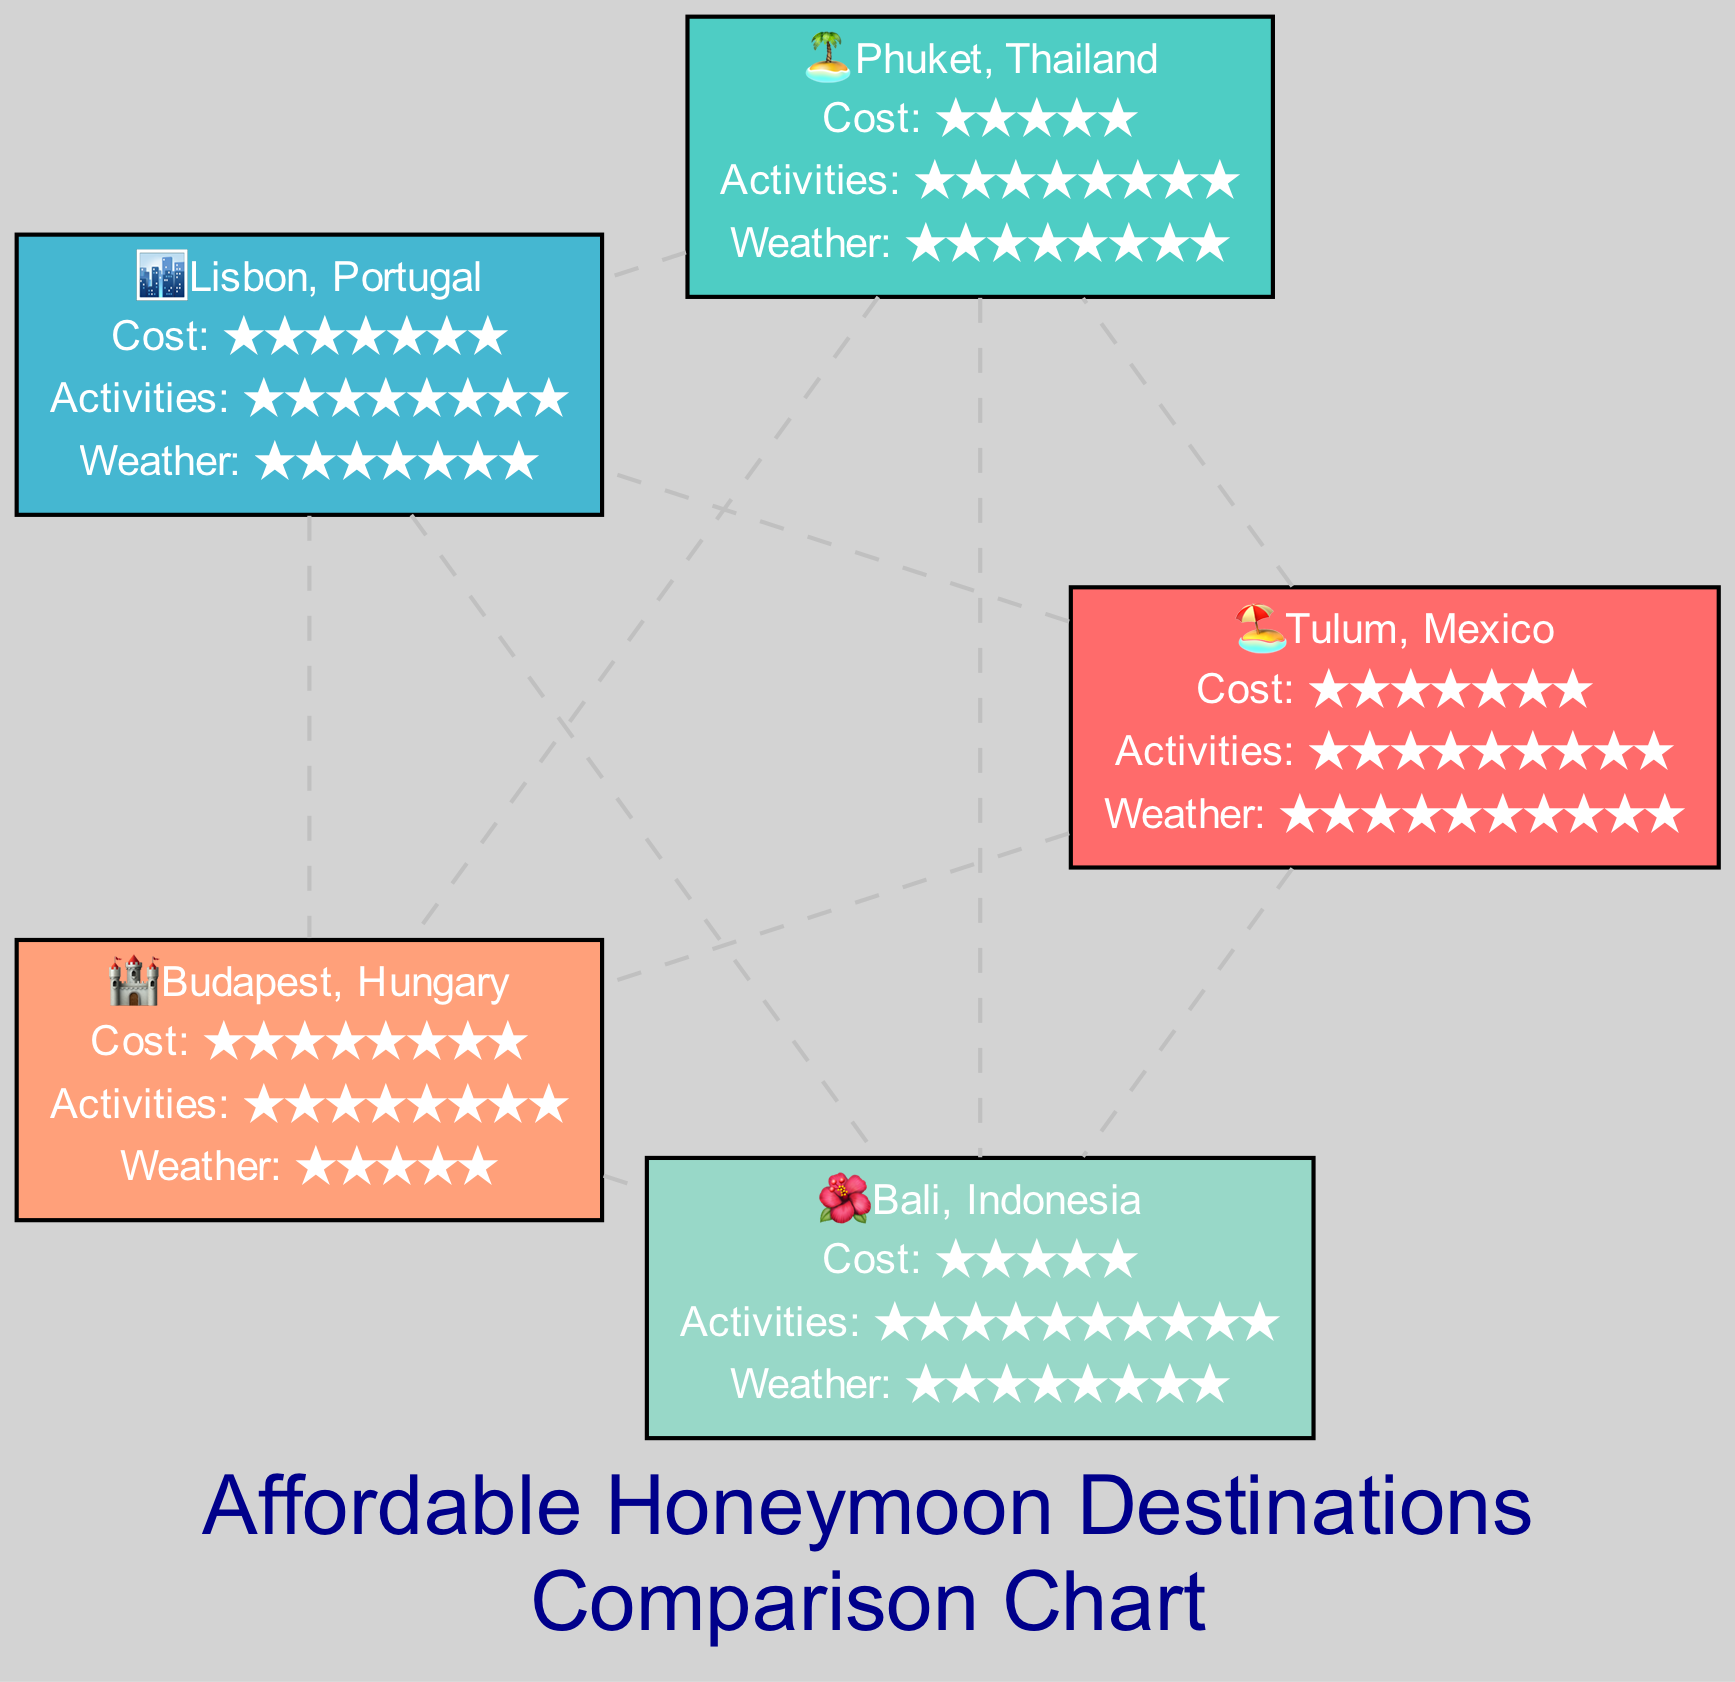What is the cost rating for Tulum, Mexico? The chart indicates a cost rating for Tulum of 7, which is shown next to Tulum’s node.
Answer: 7 Which destination has the highest activity rating? By examining the nodes, Bali has an activity rating of 10, which is higher than the other destinations.
Answer: Bali How many destinations are compared in this chart? The diagram lists five destinations in total: Tulum, Phuket, Lisbon, Budapest, and Bali.
Answer: 5 What is the weather rating for Budapest, Hungary? The node for Budapest shows a weather rating of 2 clearly displayed within its box.
Answer: 2 Which destination has the lowest cost rating? Looking at the cost ratings for each destination, Phuket has the lowest cost rating of 2.
Answer: Phuket Which pair of destinations has a cost rating difference of 1? Comparing the cost ratings, Tulum (7) and Lisbon (7) or Phuket (5) and Bali (5) have a difference of 0. However, the difference of 1 is seen between Budapest (8) and Tulum (7).
Answer: Tulum and Budapest What icon represents Phuket, Thailand? The node for Phuket is marked with an island icon, which is depicted as 🏝️ in the diagram.
Answer: island Which destination has the best overall rating for weather? Evaluating the weather ratings, Tulum has the highest with a rating of 10, making it the best.
Answer: Tulum How does the cost rating of Bali compare with that of Phuket? Bali's cost rating is 5 while Phuket's is 2, resulting in Bali being more expensive compared to Phuket.
Answer: more expensive 